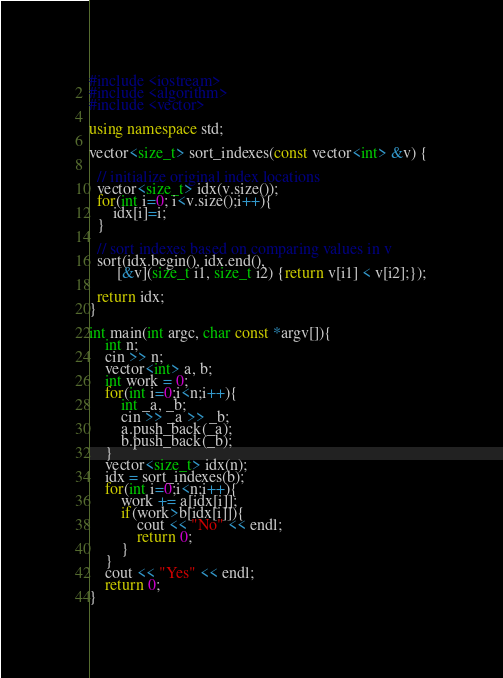<code> <loc_0><loc_0><loc_500><loc_500><_C++_>#include <iostream>
#include <algorithm>
#include <vector>

using namespace std;

vector<size_t> sort_indexes(const vector<int> &v) {

  // initialize original index locations
  vector<size_t> idx(v.size());
  for(int i=0; i<v.size();i++){
      idx[i]=i;
  }

  // sort indexes based on comparing values in v
  sort(idx.begin(), idx.end(),
       [&v](size_t i1, size_t i2) {return v[i1] < v[i2];});

  return idx;
}

int main(int argc, char const *argv[]){
    int n;
    cin >> n;
    vector<int> a, b;
    int work = 0;
    for(int i=0;i<n;i++){
        int _a, _b;
        cin >> _a >> _b;
        a.push_back(_a);
        b.push_back(_b);
    }
    vector<size_t> idx(n);
    idx = sort_indexes(b);
    for(int i=0;i<n;i++){
        work += a[idx[i]];
        if(work>b[idx[i]]){
            cout << "No" << endl;
            return 0;
        }
    }
    cout << "Yes" << endl;
    return 0;
}</code> 